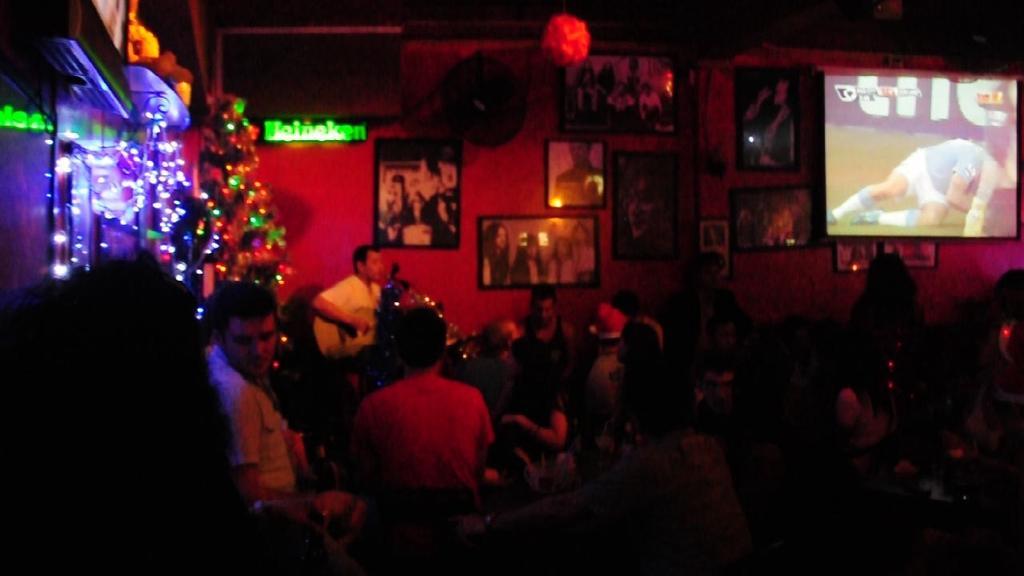Can you describe this image briefly? In this picture we can see there are groups of people sitting and a person is holding a guitar. Behind the people there is a television and a wall with photos and a tree with some decorative items. 